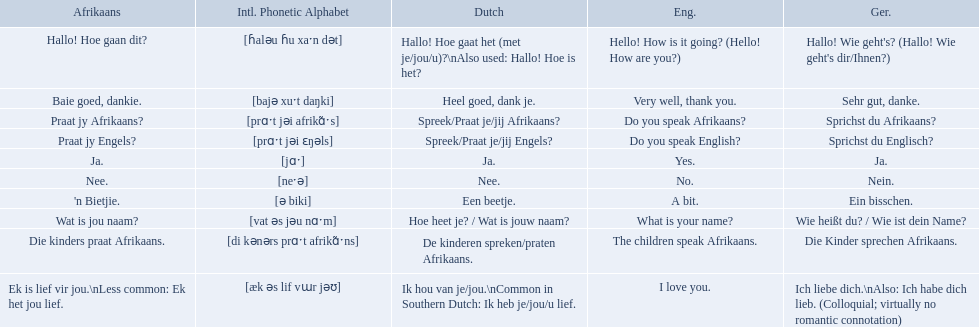What are the afrikaans phrases? Hallo! Hoe gaan dit?, Baie goed, dankie., Praat jy Afrikaans?, Praat jy Engels?, Ja., Nee., 'n Bietjie., Wat is jou naam?, Die kinders praat Afrikaans., Ek is lief vir jou.\nLess common: Ek het jou lief. For die kinders praat afrikaans, what are the translations? De kinderen spreken/praten Afrikaans., The children speak Afrikaans., Die Kinder sprechen Afrikaans. Which one is the german translation? Die Kinder sprechen Afrikaans. How would you say the phrase the children speak afrikaans in afrikaans? Die kinders praat Afrikaans. How would you say the previous phrase in german? Die Kinder sprechen Afrikaans. What are the listed afrikaans phrases? Hallo! Hoe gaan dit?, Baie goed, dankie., Praat jy Afrikaans?, Praat jy Engels?, Ja., Nee., 'n Bietjie., Wat is jou naam?, Die kinders praat Afrikaans., Ek is lief vir jou.\nLess common: Ek het jou lief. Which is die kinders praat afrikaans? Die kinders praat Afrikaans. What is its german translation? Die Kinder sprechen Afrikaans. What are all of the afrikaans phrases shown in the table? Hallo! Hoe gaan dit?, Baie goed, dankie., Praat jy Afrikaans?, Praat jy Engels?, Ja., Nee., 'n Bietjie., Wat is jou naam?, Die kinders praat Afrikaans., Ek is lief vir jou.\nLess common: Ek het jou lief. Of those, which translates into english as do you speak afrikaans?? Praat jy Afrikaans?. Which phrases are said in africaans? Hallo! Hoe gaan dit?, Baie goed, dankie., Praat jy Afrikaans?, Praat jy Engels?, Ja., Nee., 'n Bietjie., Wat is jou naam?, Die kinders praat Afrikaans., Ek is lief vir jou.\nLess common: Ek het jou lief. Which of these mean how do you speak afrikaans? Praat jy Afrikaans?. What are all of the afrikaans phrases in the list? Hallo! Hoe gaan dit?, Baie goed, dankie., Praat jy Afrikaans?, Praat jy Engels?, Ja., Nee., 'n Bietjie., Wat is jou naam?, Die kinders praat Afrikaans., Ek is lief vir jou.\nLess common: Ek het jou lief. What is the english translation of each phrase? Hello! How is it going? (Hello! How are you?), Very well, thank you., Do you speak Afrikaans?, Do you speak English?, Yes., No., A bit., What is your name?, The children speak Afrikaans., I love you. And which afrikaans phrase translated to do you speak afrikaans? Praat jy Afrikaans?. 